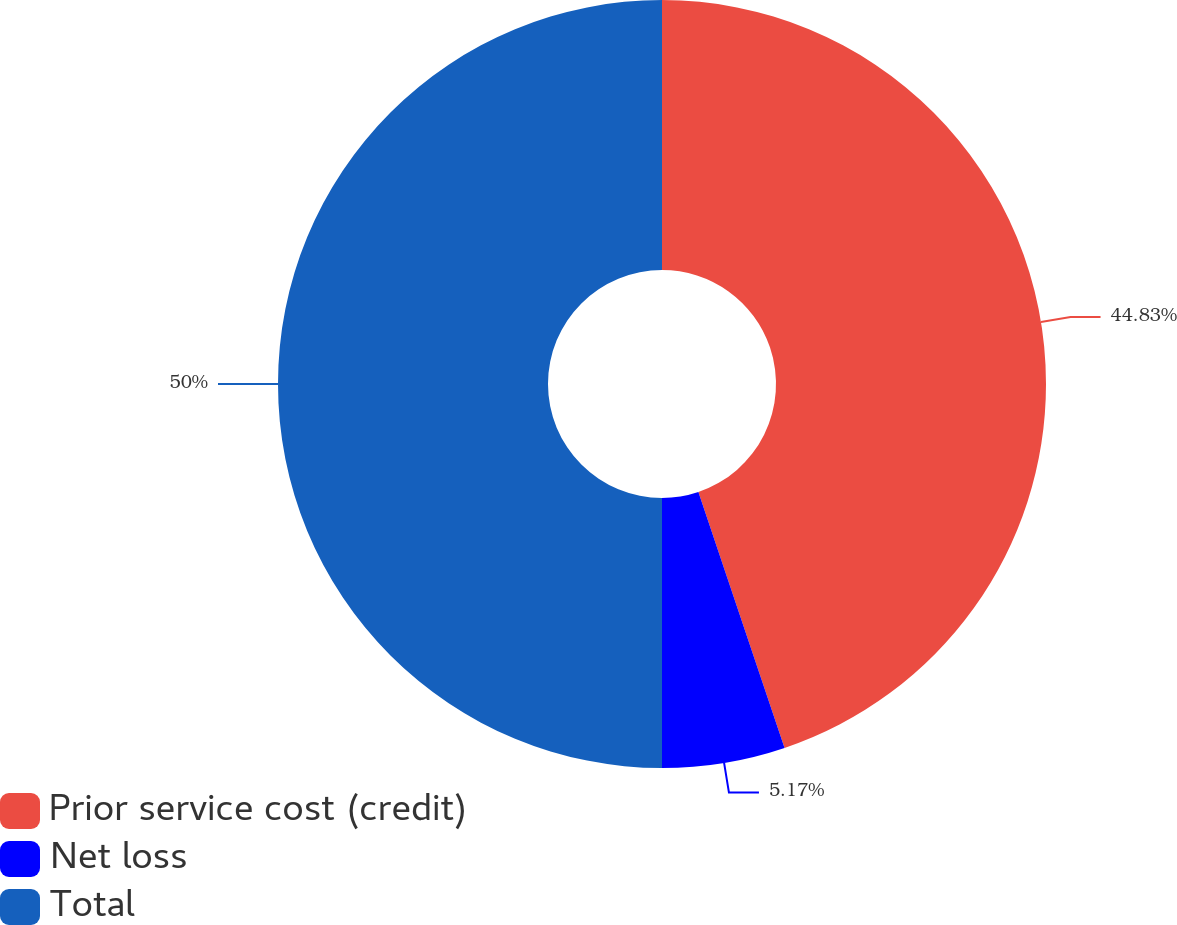Convert chart to OTSL. <chart><loc_0><loc_0><loc_500><loc_500><pie_chart><fcel>Prior service cost (credit)<fcel>Net loss<fcel>Total<nl><fcel>44.83%<fcel>5.17%<fcel>50.0%<nl></chart> 